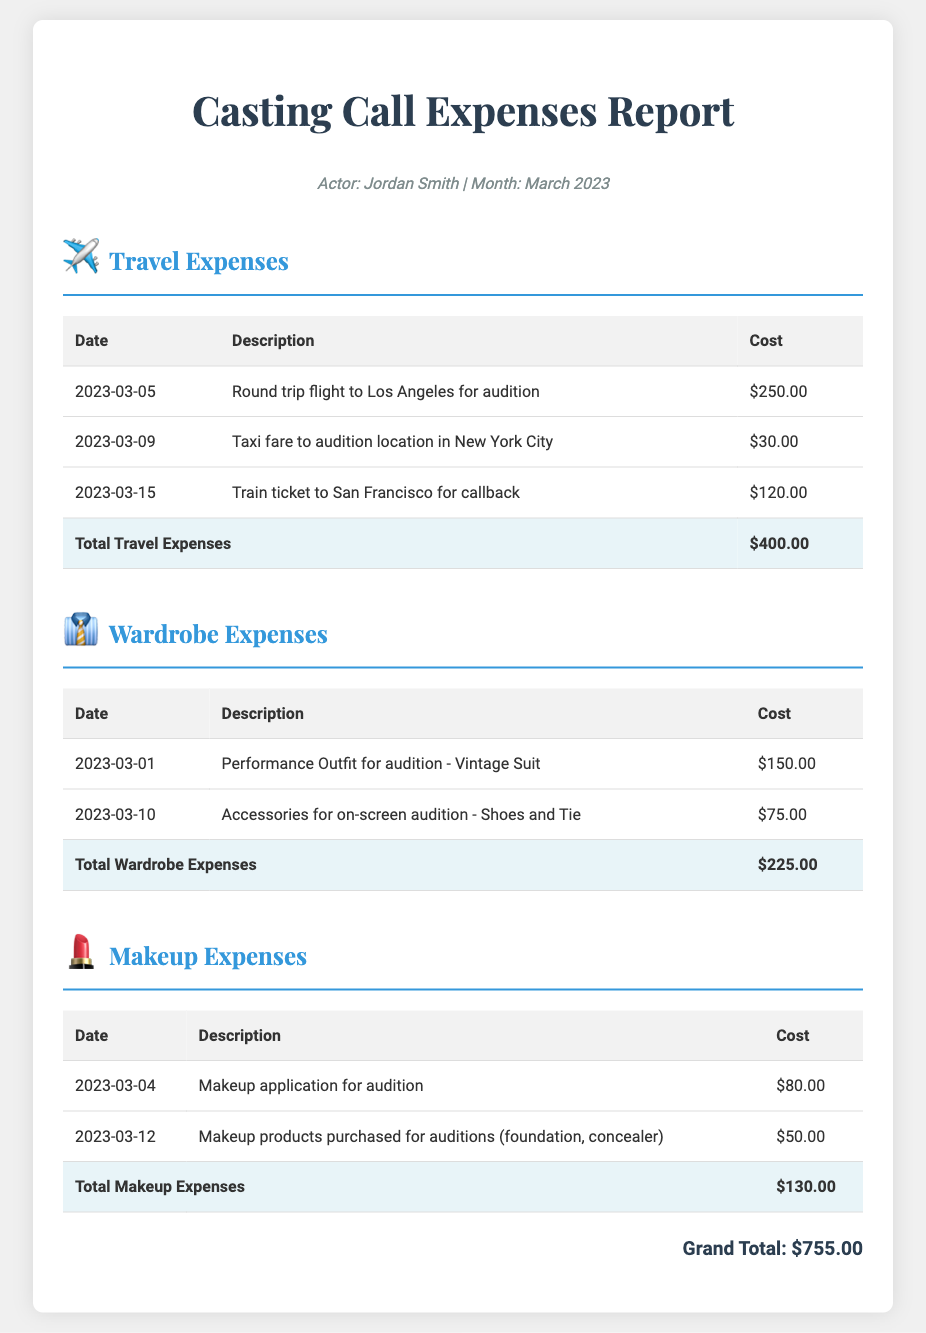What is the total travel expense? The total travel expense is provided in the travel section of the report, which sums up to $400.00.
Answer: $400.00 What item was purchased for $150.00? The wardrobe section lists a "Performance Outfit for audition - Vintage Suit" which costs $150.00.
Answer: Performance Outfit for audition - Vintage Suit How many taxi fares were recorded? The travel section has one entry explicitly mentioning taxi fare, indicating one recorded taxi fare.
Answer: 1 What was the total makeup expense? The total makeup expense is the sum of all makeup-related costs in the makeup table, which is $130.00.
Answer: $130.00 What was the date of the train ticket purchase? The date for the train ticket purchase is mentioned in the travel section as "2023-03-15."
Answer: 2023-03-15 What is the grand total of all expenses? The grand total is indicated at the bottom of the report, summarizing all listed expenses to $755.00.
Answer: $755.00 What accessories were purchased for the audition? The wardrobe section includes "Shoes and Tie" as accessories purchased for the audition, listed under accessories.
Answer: Shoes and Tie What was purchased on 2023-03-12? The makeup section records makeup products like foundation and concealer being purchased on this date.
Answer: Makeup products purchased for auditions (foundation, concealer) Which city was a round trip flight taken to? The travel section specifies that a round trip flight was taken to "Los Angeles" for an audition.
Answer: Los Angeles 